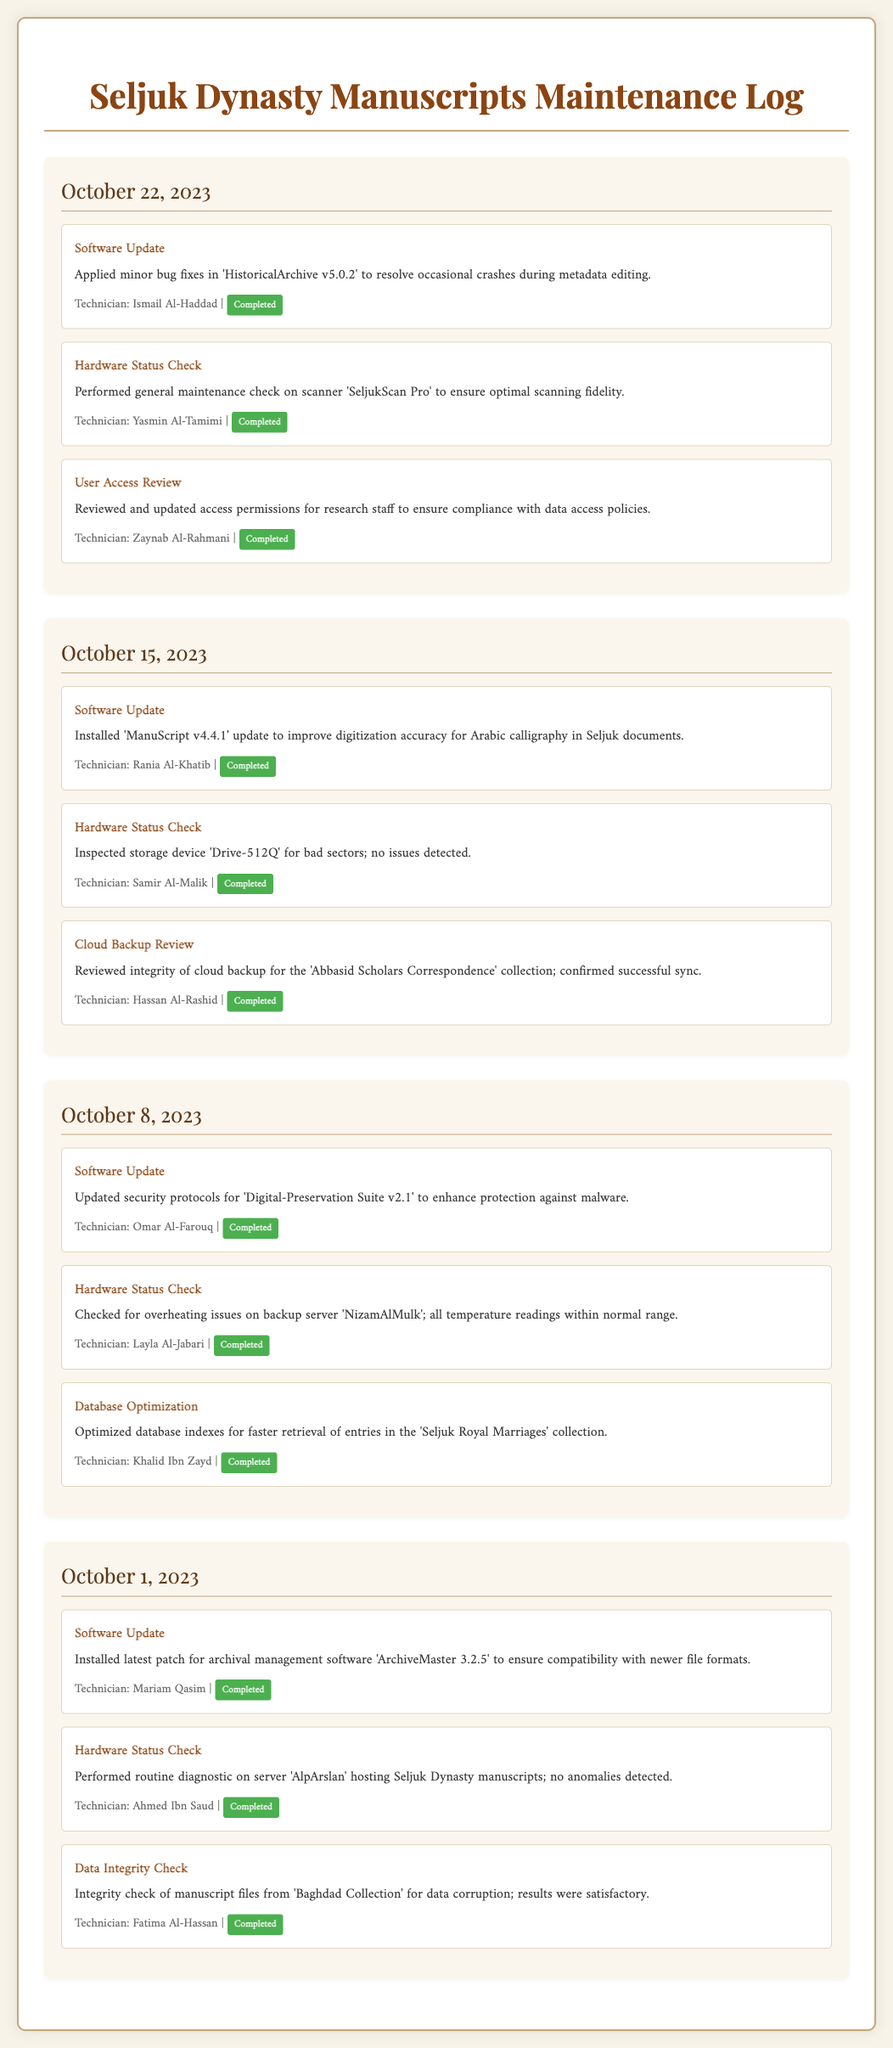What date was the software update applied? The software update is noted on October 22, 2023, as mentioned in the log.
Answer: October 22, 2023 Who performed the hardware status check on October 15, 2023? The technician for the hardware status check on that date was Samir Al-Malik.
Answer: Samir Al-Malik What was updated in the software on October 8, 2023? The log states that security protocols for 'Digital-Preservation Suite v2.1' were updated on this date.
Answer: Security protocols for 'Digital-Preservation Suite v2.1' How many software updates were completed in October 2023? There are three software updates detailed in the entries for October 1, 8, 15, and 22, indicating a total of four.
Answer: Four What was the status of the tasks recorded in the log? All tasks recorded in the maintenance log are marked with a status of "Completed."
Answer: Completed What type of check was conducted on the scanner 'SeljukScan Pro'? The maintenance log specifies that a general maintenance check was performed.
Answer: General maintenance check Who reviewed the user access on October 22, 2023? Zaynab Al-Rahmani conducted the user access review on this date.
Answer: Zaynab Al-Rahmani What was optimized on October 8, 2023? The maintenance log includes the optimization of database indexes for faster retrieval in the 'Seljuk Royal Marriages' collection.
Answer: Database indexes for 'Seljuk Royal Marriages' What was checked for overheating issues? The backup server 'NizamAlMulk' was checked for overheating issues as recorded in the log.
Answer: Backup server 'NizamAlMulk' 